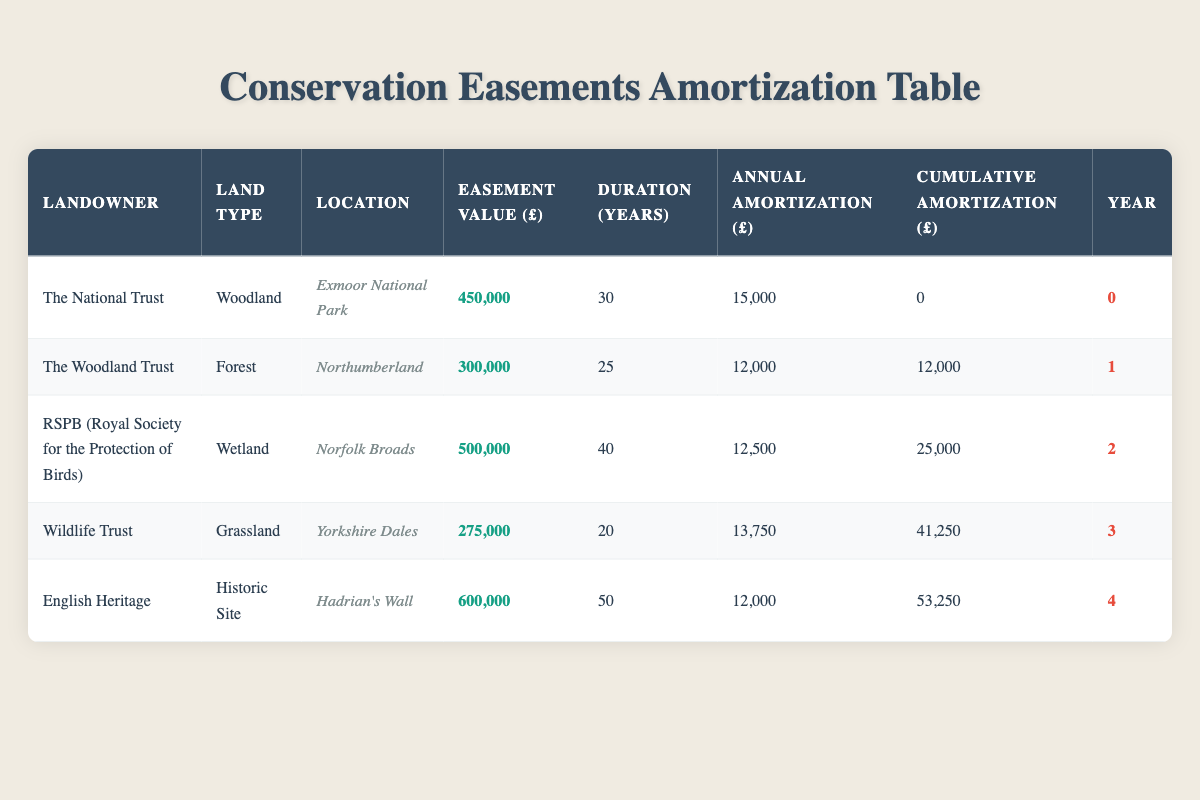What is the annual amortization for the RSPB's wetland easement? From the table, for the row concerning the RSPB (Royal Society for the Protection of Birds), the annual amortization is listed as £12,500.
Answer: £12,500 How much cumulative amortization has Wildlife Trust achieved by year 3? The Wildlife Trust's cumulative amortization by year 3 is listed as £41,250 in the table.
Answer: £41,250 What is the total easement value for the conservation easements listed? To find the total easement value, we sum the values from each landowner: 450,000 + 300,000 + 500,000 + 275,000 + 600,000 = 2,125,000.
Answer: £2,125,000 Is the cumulative amortization for English Heritage greater than £50,000 by year 4? In the table, English Heritage's cumulative amortization is listed as £53,250. Since £53,250 is greater than £50,000, the answer is yes.
Answer: Yes What is the average annual amortization across all conservation easements? To calculate the average, we sum the annual amortization amounts: 15,000 + 12,000 + 12,500 + 13,750 + 12,000 = 65,250. There are 5 landowners, so the average is 65,250 / 5 = 13,050.
Answer: £13,050 Which landowner has the longest duration for their conservation easement? From the table, English Heritage has the longest duration of 50 years for their historic site, compared to the others.
Answer: English Heritage How much cumulative amortization has been achieved by year 2 across all landowners? By year 2, we total all cumulative amortization values: The National Trust (0) + The Woodland Trust (12,000) + RSPB (25,000) = 37,000.
Answer: £37,000 Is the easement value of the National Trust lower than the average easement value? The National Trust's easement value is £450,000. The average value calculated earlier is £425,000 (2,125,000 / 5), so £450,000 is higher than the average, making the answer no.
Answer: No What is the difference in cumulative amortization between the Wildlife Trust and the RSPB after year 2? The cumulative amortization for Wildlife Trust is £41,250 and for RSPB is £25,000. The difference is 41,250 - 25,000 = 16,250.
Answer: £16,250 